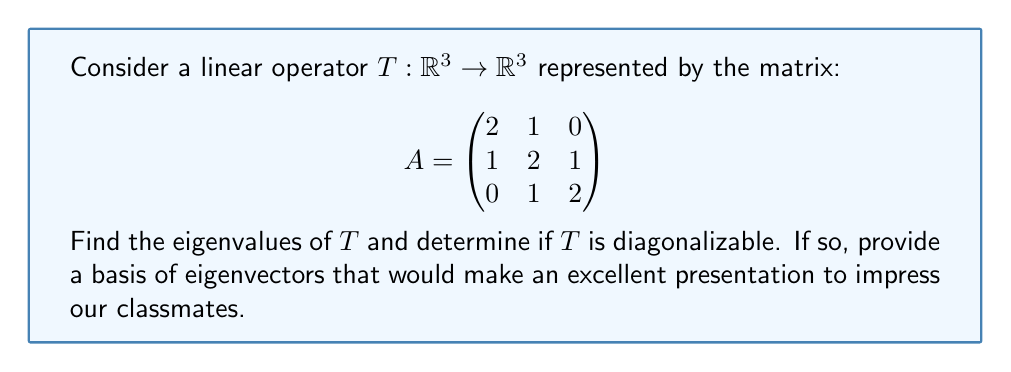Give your solution to this math problem. 1) To find the eigenvalues, we need to solve the characteristic equation:
   $$\det(A - \lambda I) = 0$$

2) Expanding the determinant:
   $$\begin{vmatrix}
   2-\lambda & 1 & 0 \\
   1 & 2-\lambda & 1 \\
   0 & 1 & 2-\lambda
   \end{vmatrix} = 0$$

3) This gives us:
   $$(2-\lambda)[(2-\lambda)^2 - 1] - 1(1-0) = 0$$
   $$(2-\lambda)[(2-\lambda)^2 - 1] - 1 = 0$$
   $$(2-\lambda)(4-4\lambda+\lambda^2 - 1) - 1 = 0$$
   $$(2-\lambda)(3-4\lambda+\lambda^2) - 1 = 0$$
   $$6-12\lambda+3\lambda^2-8+16\lambda-4\lambda^2+2\lambda-4\lambda^2+\lambda^3 - 1 = 0$$
   $$\lambda^3 - 3\lambda^2 + 3\lambda - 3 = 0$$
   $$(\lambda - 1)(\lambda - 1)(\lambda - 1) = 0$$

4) Therefore, the eigenvalue is $\lambda = 1$ with algebraic multiplicity 3.

5) To check for diagonalizability, we need to find the geometric multiplicity:
   For $\lambda = 1$, solve $(A - I)x = 0$:
   $$\begin{pmatrix}
   1 & 1 & 0 \\
   1 & 1 & 1 \\
   0 & 1 & 1
   \end{pmatrix}\begin{pmatrix}
   x \\
   y \\
   z
   \end{pmatrix} = \begin{pmatrix}
   0 \\
   0 \\
   0
   \end{pmatrix}$$

6) This gives us:
   $x + y = 0$
   $x + y + z = 0$
   $y + z = 0$

7) Solving this system, we get:
   $x = t$, $y = -t$, $z = t$ where $t$ is any real number.

8) The eigenvector is therefore $v = t(1, -1, 1)^T$

9) The geometric multiplicity is 1, which is less than the algebraic multiplicity (3).

10) Therefore, $T$ is not diagonalizable.
Answer: Eigenvalue: $\lambda = 1$ (multiplicity 3). Not diagonalizable. Eigenvector: $(1, -1, 1)^T$. 